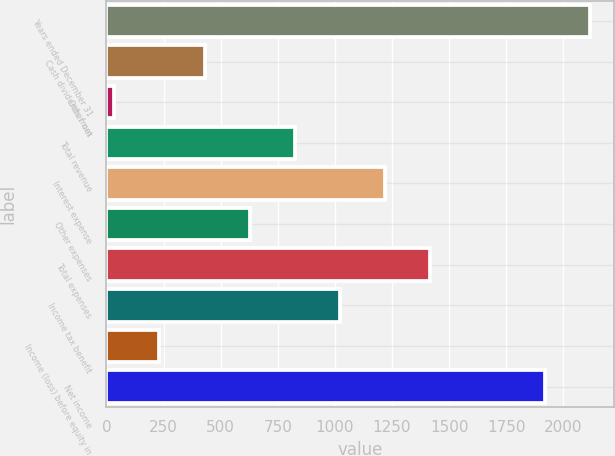Convert chart to OTSL. <chart><loc_0><loc_0><loc_500><loc_500><bar_chart><fcel>Years ended December 31<fcel>Cash dividends from<fcel>Other net<fcel>Total revenue<fcel>Interest expense<fcel>Other expenses<fcel>Total expenses<fcel>Income tax benefit<fcel>Income (loss) before equity in<fcel>Net income<nl><fcel>2117.7<fcel>429.4<fcel>34<fcel>824.8<fcel>1220.2<fcel>627.1<fcel>1417.9<fcel>1022.5<fcel>231.7<fcel>1920<nl></chart> 